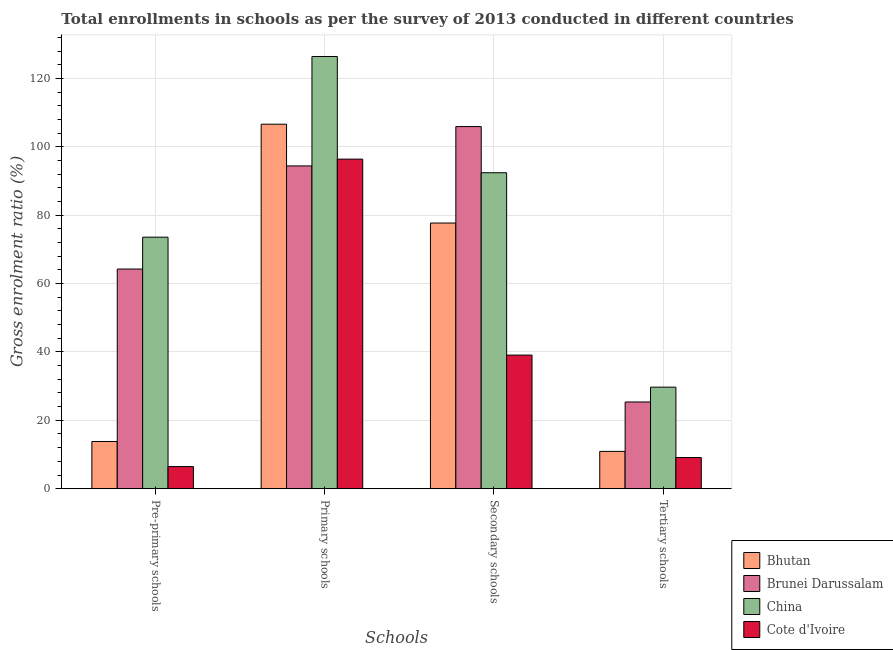How many groups of bars are there?
Offer a very short reply. 4. Are the number of bars per tick equal to the number of legend labels?
Give a very brief answer. Yes. What is the label of the 2nd group of bars from the left?
Ensure brevity in your answer.  Primary schools. What is the gross enrolment ratio in pre-primary schools in Bhutan?
Your answer should be very brief. 13.79. Across all countries, what is the maximum gross enrolment ratio in pre-primary schools?
Offer a terse response. 73.56. Across all countries, what is the minimum gross enrolment ratio in tertiary schools?
Keep it short and to the point. 9.1. In which country was the gross enrolment ratio in pre-primary schools minimum?
Give a very brief answer. Cote d'Ivoire. What is the total gross enrolment ratio in pre-primary schools in the graph?
Provide a succinct answer. 158.06. What is the difference between the gross enrolment ratio in secondary schools in Cote d'Ivoire and that in China?
Provide a short and direct response. -53.33. What is the difference between the gross enrolment ratio in primary schools in China and the gross enrolment ratio in tertiary schools in Bhutan?
Offer a very short reply. 115.51. What is the average gross enrolment ratio in tertiary schools per country?
Offer a very short reply. 18.77. What is the difference between the gross enrolment ratio in tertiary schools and gross enrolment ratio in primary schools in Bhutan?
Ensure brevity in your answer.  -95.7. What is the ratio of the gross enrolment ratio in secondary schools in Brunei Darussalam to that in China?
Provide a short and direct response. 1.15. Is the gross enrolment ratio in pre-primary schools in Bhutan less than that in Cote d'Ivoire?
Your response must be concise. No. Is the difference between the gross enrolment ratio in secondary schools in Bhutan and Cote d'Ivoire greater than the difference between the gross enrolment ratio in pre-primary schools in Bhutan and Cote d'Ivoire?
Offer a terse response. Yes. What is the difference between the highest and the second highest gross enrolment ratio in secondary schools?
Keep it short and to the point. 13.5. What is the difference between the highest and the lowest gross enrolment ratio in primary schools?
Provide a short and direct response. 32.01. Is the sum of the gross enrolment ratio in tertiary schools in China and Cote d'Ivoire greater than the maximum gross enrolment ratio in primary schools across all countries?
Provide a succinct answer. No. Is it the case that in every country, the sum of the gross enrolment ratio in pre-primary schools and gross enrolment ratio in primary schools is greater than the sum of gross enrolment ratio in secondary schools and gross enrolment ratio in tertiary schools?
Keep it short and to the point. Yes. What does the 4th bar from the left in Secondary schools represents?
Provide a short and direct response. Cote d'Ivoire. What does the 3rd bar from the right in Primary schools represents?
Your answer should be compact. Brunei Darussalam. How many countries are there in the graph?
Your response must be concise. 4. What is the difference between two consecutive major ticks on the Y-axis?
Provide a short and direct response. 20. Are the values on the major ticks of Y-axis written in scientific E-notation?
Ensure brevity in your answer.  No. Does the graph contain grids?
Offer a very short reply. Yes. How many legend labels are there?
Your answer should be compact. 4. How are the legend labels stacked?
Give a very brief answer. Vertical. What is the title of the graph?
Offer a terse response. Total enrollments in schools as per the survey of 2013 conducted in different countries. What is the label or title of the X-axis?
Your answer should be very brief. Schools. What is the Gross enrolment ratio (%) in Bhutan in Pre-primary schools?
Give a very brief answer. 13.79. What is the Gross enrolment ratio (%) in Brunei Darussalam in Pre-primary schools?
Offer a very short reply. 64.24. What is the Gross enrolment ratio (%) of China in Pre-primary schools?
Offer a terse response. 73.56. What is the Gross enrolment ratio (%) of Cote d'Ivoire in Pre-primary schools?
Your answer should be compact. 6.46. What is the Gross enrolment ratio (%) of Bhutan in Primary schools?
Your response must be concise. 106.61. What is the Gross enrolment ratio (%) of Brunei Darussalam in Primary schools?
Your answer should be compact. 94.41. What is the Gross enrolment ratio (%) of China in Primary schools?
Provide a succinct answer. 126.42. What is the Gross enrolment ratio (%) of Cote d'Ivoire in Primary schools?
Provide a short and direct response. 96.4. What is the Gross enrolment ratio (%) of Bhutan in Secondary schools?
Offer a terse response. 77.7. What is the Gross enrolment ratio (%) of Brunei Darussalam in Secondary schools?
Offer a very short reply. 105.91. What is the Gross enrolment ratio (%) of China in Secondary schools?
Give a very brief answer. 92.41. What is the Gross enrolment ratio (%) in Cote d'Ivoire in Secondary schools?
Keep it short and to the point. 39.08. What is the Gross enrolment ratio (%) of Bhutan in Tertiary schools?
Your answer should be very brief. 10.91. What is the Gross enrolment ratio (%) in Brunei Darussalam in Tertiary schools?
Offer a terse response. 25.36. What is the Gross enrolment ratio (%) in China in Tertiary schools?
Your response must be concise. 29.7. What is the Gross enrolment ratio (%) of Cote d'Ivoire in Tertiary schools?
Make the answer very short. 9.1. Across all Schools, what is the maximum Gross enrolment ratio (%) in Bhutan?
Ensure brevity in your answer.  106.61. Across all Schools, what is the maximum Gross enrolment ratio (%) in Brunei Darussalam?
Your answer should be compact. 105.91. Across all Schools, what is the maximum Gross enrolment ratio (%) of China?
Your response must be concise. 126.42. Across all Schools, what is the maximum Gross enrolment ratio (%) in Cote d'Ivoire?
Your answer should be compact. 96.4. Across all Schools, what is the minimum Gross enrolment ratio (%) in Bhutan?
Your answer should be very brief. 10.91. Across all Schools, what is the minimum Gross enrolment ratio (%) of Brunei Darussalam?
Your response must be concise. 25.36. Across all Schools, what is the minimum Gross enrolment ratio (%) of China?
Make the answer very short. 29.7. Across all Schools, what is the minimum Gross enrolment ratio (%) in Cote d'Ivoire?
Your answer should be very brief. 6.46. What is the total Gross enrolment ratio (%) of Bhutan in the graph?
Ensure brevity in your answer.  209.01. What is the total Gross enrolment ratio (%) in Brunei Darussalam in the graph?
Offer a terse response. 289.92. What is the total Gross enrolment ratio (%) in China in the graph?
Your response must be concise. 322.09. What is the total Gross enrolment ratio (%) of Cote d'Ivoire in the graph?
Provide a short and direct response. 151.04. What is the difference between the Gross enrolment ratio (%) of Bhutan in Pre-primary schools and that in Primary schools?
Give a very brief answer. -92.81. What is the difference between the Gross enrolment ratio (%) of Brunei Darussalam in Pre-primary schools and that in Primary schools?
Your answer should be compact. -30.16. What is the difference between the Gross enrolment ratio (%) of China in Pre-primary schools and that in Primary schools?
Ensure brevity in your answer.  -52.85. What is the difference between the Gross enrolment ratio (%) in Cote d'Ivoire in Pre-primary schools and that in Primary schools?
Ensure brevity in your answer.  -89.93. What is the difference between the Gross enrolment ratio (%) in Bhutan in Pre-primary schools and that in Secondary schools?
Your answer should be very brief. -63.91. What is the difference between the Gross enrolment ratio (%) of Brunei Darussalam in Pre-primary schools and that in Secondary schools?
Provide a short and direct response. -41.67. What is the difference between the Gross enrolment ratio (%) of China in Pre-primary schools and that in Secondary schools?
Your answer should be compact. -18.84. What is the difference between the Gross enrolment ratio (%) in Cote d'Ivoire in Pre-primary schools and that in Secondary schools?
Give a very brief answer. -32.61. What is the difference between the Gross enrolment ratio (%) in Bhutan in Pre-primary schools and that in Tertiary schools?
Offer a terse response. 2.88. What is the difference between the Gross enrolment ratio (%) in Brunei Darussalam in Pre-primary schools and that in Tertiary schools?
Provide a short and direct response. 38.88. What is the difference between the Gross enrolment ratio (%) in China in Pre-primary schools and that in Tertiary schools?
Your response must be concise. 43.87. What is the difference between the Gross enrolment ratio (%) in Cote d'Ivoire in Pre-primary schools and that in Tertiary schools?
Provide a succinct answer. -2.64. What is the difference between the Gross enrolment ratio (%) in Bhutan in Primary schools and that in Secondary schools?
Offer a terse response. 28.91. What is the difference between the Gross enrolment ratio (%) of Brunei Darussalam in Primary schools and that in Secondary schools?
Your response must be concise. -11.5. What is the difference between the Gross enrolment ratio (%) of China in Primary schools and that in Secondary schools?
Provide a succinct answer. 34.01. What is the difference between the Gross enrolment ratio (%) of Cote d'Ivoire in Primary schools and that in Secondary schools?
Make the answer very short. 57.32. What is the difference between the Gross enrolment ratio (%) in Bhutan in Primary schools and that in Tertiary schools?
Provide a short and direct response. 95.7. What is the difference between the Gross enrolment ratio (%) of Brunei Darussalam in Primary schools and that in Tertiary schools?
Offer a terse response. 69.04. What is the difference between the Gross enrolment ratio (%) of China in Primary schools and that in Tertiary schools?
Offer a terse response. 96.72. What is the difference between the Gross enrolment ratio (%) of Cote d'Ivoire in Primary schools and that in Tertiary schools?
Your response must be concise. 87.29. What is the difference between the Gross enrolment ratio (%) of Bhutan in Secondary schools and that in Tertiary schools?
Provide a short and direct response. 66.79. What is the difference between the Gross enrolment ratio (%) in Brunei Darussalam in Secondary schools and that in Tertiary schools?
Your answer should be compact. 80.55. What is the difference between the Gross enrolment ratio (%) in China in Secondary schools and that in Tertiary schools?
Ensure brevity in your answer.  62.71. What is the difference between the Gross enrolment ratio (%) of Cote d'Ivoire in Secondary schools and that in Tertiary schools?
Give a very brief answer. 29.97. What is the difference between the Gross enrolment ratio (%) of Bhutan in Pre-primary schools and the Gross enrolment ratio (%) of Brunei Darussalam in Primary schools?
Ensure brevity in your answer.  -80.61. What is the difference between the Gross enrolment ratio (%) in Bhutan in Pre-primary schools and the Gross enrolment ratio (%) in China in Primary schools?
Give a very brief answer. -112.62. What is the difference between the Gross enrolment ratio (%) of Bhutan in Pre-primary schools and the Gross enrolment ratio (%) of Cote d'Ivoire in Primary schools?
Offer a terse response. -82.6. What is the difference between the Gross enrolment ratio (%) in Brunei Darussalam in Pre-primary schools and the Gross enrolment ratio (%) in China in Primary schools?
Offer a terse response. -62.17. What is the difference between the Gross enrolment ratio (%) in Brunei Darussalam in Pre-primary schools and the Gross enrolment ratio (%) in Cote d'Ivoire in Primary schools?
Provide a succinct answer. -32.15. What is the difference between the Gross enrolment ratio (%) of China in Pre-primary schools and the Gross enrolment ratio (%) of Cote d'Ivoire in Primary schools?
Keep it short and to the point. -22.83. What is the difference between the Gross enrolment ratio (%) of Bhutan in Pre-primary schools and the Gross enrolment ratio (%) of Brunei Darussalam in Secondary schools?
Provide a short and direct response. -92.11. What is the difference between the Gross enrolment ratio (%) in Bhutan in Pre-primary schools and the Gross enrolment ratio (%) in China in Secondary schools?
Provide a succinct answer. -78.61. What is the difference between the Gross enrolment ratio (%) in Bhutan in Pre-primary schools and the Gross enrolment ratio (%) in Cote d'Ivoire in Secondary schools?
Ensure brevity in your answer.  -25.28. What is the difference between the Gross enrolment ratio (%) in Brunei Darussalam in Pre-primary schools and the Gross enrolment ratio (%) in China in Secondary schools?
Keep it short and to the point. -28.17. What is the difference between the Gross enrolment ratio (%) of Brunei Darussalam in Pre-primary schools and the Gross enrolment ratio (%) of Cote d'Ivoire in Secondary schools?
Ensure brevity in your answer.  25.17. What is the difference between the Gross enrolment ratio (%) of China in Pre-primary schools and the Gross enrolment ratio (%) of Cote d'Ivoire in Secondary schools?
Make the answer very short. 34.49. What is the difference between the Gross enrolment ratio (%) of Bhutan in Pre-primary schools and the Gross enrolment ratio (%) of Brunei Darussalam in Tertiary schools?
Your response must be concise. -11.57. What is the difference between the Gross enrolment ratio (%) of Bhutan in Pre-primary schools and the Gross enrolment ratio (%) of China in Tertiary schools?
Provide a succinct answer. -15.9. What is the difference between the Gross enrolment ratio (%) of Bhutan in Pre-primary schools and the Gross enrolment ratio (%) of Cote d'Ivoire in Tertiary schools?
Your answer should be very brief. 4.69. What is the difference between the Gross enrolment ratio (%) in Brunei Darussalam in Pre-primary schools and the Gross enrolment ratio (%) in China in Tertiary schools?
Give a very brief answer. 34.55. What is the difference between the Gross enrolment ratio (%) in Brunei Darussalam in Pre-primary schools and the Gross enrolment ratio (%) in Cote d'Ivoire in Tertiary schools?
Make the answer very short. 55.14. What is the difference between the Gross enrolment ratio (%) of China in Pre-primary schools and the Gross enrolment ratio (%) of Cote d'Ivoire in Tertiary schools?
Provide a short and direct response. 64.46. What is the difference between the Gross enrolment ratio (%) in Bhutan in Primary schools and the Gross enrolment ratio (%) in Brunei Darussalam in Secondary schools?
Offer a very short reply. 0.7. What is the difference between the Gross enrolment ratio (%) in Bhutan in Primary schools and the Gross enrolment ratio (%) in China in Secondary schools?
Your response must be concise. 14.2. What is the difference between the Gross enrolment ratio (%) in Bhutan in Primary schools and the Gross enrolment ratio (%) in Cote d'Ivoire in Secondary schools?
Provide a short and direct response. 67.53. What is the difference between the Gross enrolment ratio (%) in Brunei Darussalam in Primary schools and the Gross enrolment ratio (%) in China in Secondary schools?
Ensure brevity in your answer.  2. What is the difference between the Gross enrolment ratio (%) of Brunei Darussalam in Primary schools and the Gross enrolment ratio (%) of Cote d'Ivoire in Secondary schools?
Your response must be concise. 55.33. What is the difference between the Gross enrolment ratio (%) in China in Primary schools and the Gross enrolment ratio (%) in Cote d'Ivoire in Secondary schools?
Give a very brief answer. 87.34. What is the difference between the Gross enrolment ratio (%) in Bhutan in Primary schools and the Gross enrolment ratio (%) in Brunei Darussalam in Tertiary schools?
Make the answer very short. 81.25. What is the difference between the Gross enrolment ratio (%) of Bhutan in Primary schools and the Gross enrolment ratio (%) of China in Tertiary schools?
Give a very brief answer. 76.91. What is the difference between the Gross enrolment ratio (%) of Bhutan in Primary schools and the Gross enrolment ratio (%) of Cote d'Ivoire in Tertiary schools?
Your answer should be very brief. 97.5. What is the difference between the Gross enrolment ratio (%) of Brunei Darussalam in Primary schools and the Gross enrolment ratio (%) of China in Tertiary schools?
Your answer should be very brief. 64.71. What is the difference between the Gross enrolment ratio (%) of Brunei Darussalam in Primary schools and the Gross enrolment ratio (%) of Cote d'Ivoire in Tertiary schools?
Provide a short and direct response. 85.3. What is the difference between the Gross enrolment ratio (%) of China in Primary schools and the Gross enrolment ratio (%) of Cote d'Ivoire in Tertiary schools?
Keep it short and to the point. 117.31. What is the difference between the Gross enrolment ratio (%) of Bhutan in Secondary schools and the Gross enrolment ratio (%) of Brunei Darussalam in Tertiary schools?
Ensure brevity in your answer.  52.34. What is the difference between the Gross enrolment ratio (%) of Bhutan in Secondary schools and the Gross enrolment ratio (%) of China in Tertiary schools?
Make the answer very short. 48. What is the difference between the Gross enrolment ratio (%) of Bhutan in Secondary schools and the Gross enrolment ratio (%) of Cote d'Ivoire in Tertiary schools?
Provide a succinct answer. 68.6. What is the difference between the Gross enrolment ratio (%) in Brunei Darussalam in Secondary schools and the Gross enrolment ratio (%) in China in Tertiary schools?
Provide a short and direct response. 76.21. What is the difference between the Gross enrolment ratio (%) in Brunei Darussalam in Secondary schools and the Gross enrolment ratio (%) in Cote d'Ivoire in Tertiary schools?
Ensure brevity in your answer.  96.81. What is the difference between the Gross enrolment ratio (%) in China in Secondary schools and the Gross enrolment ratio (%) in Cote d'Ivoire in Tertiary schools?
Your response must be concise. 83.31. What is the average Gross enrolment ratio (%) in Bhutan per Schools?
Ensure brevity in your answer.  52.25. What is the average Gross enrolment ratio (%) in Brunei Darussalam per Schools?
Offer a very short reply. 72.48. What is the average Gross enrolment ratio (%) in China per Schools?
Give a very brief answer. 80.52. What is the average Gross enrolment ratio (%) in Cote d'Ivoire per Schools?
Keep it short and to the point. 37.76. What is the difference between the Gross enrolment ratio (%) of Bhutan and Gross enrolment ratio (%) of Brunei Darussalam in Pre-primary schools?
Ensure brevity in your answer.  -50.45. What is the difference between the Gross enrolment ratio (%) of Bhutan and Gross enrolment ratio (%) of China in Pre-primary schools?
Give a very brief answer. -59.77. What is the difference between the Gross enrolment ratio (%) of Bhutan and Gross enrolment ratio (%) of Cote d'Ivoire in Pre-primary schools?
Give a very brief answer. 7.33. What is the difference between the Gross enrolment ratio (%) in Brunei Darussalam and Gross enrolment ratio (%) in China in Pre-primary schools?
Provide a succinct answer. -9.32. What is the difference between the Gross enrolment ratio (%) of Brunei Darussalam and Gross enrolment ratio (%) of Cote d'Ivoire in Pre-primary schools?
Offer a terse response. 57.78. What is the difference between the Gross enrolment ratio (%) of China and Gross enrolment ratio (%) of Cote d'Ivoire in Pre-primary schools?
Your answer should be compact. 67.1. What is the difference between the Gross enrolment ratio (%) of Bhutan and Gross enrolment ratio (%) of Brunei Darussalam in Primary schools?
Provide a succinct answer. 12.2. What is the difference between the Gross enrolment ratio (%) of Bhutan and Gross enrolment ratio (%) of China in Primary schools?
Provide a succinct answer. -19.81. What is the difference between the Gross enrolment ratio (%) of Bhutan and Gross enrolment ratio (%) of Cote d'Ivoire in Primary schools?
Your response must be concise. 10.21. What is the difference between the Gross enrolment ratio (%) in Brunei Darussalam and Gross enrolment ratio (%) in China in Primary schools?
Your response must be concise. -32.01. What is the difference between the Gross enrolment ratio (%) of Brunei Darussalam and Gross enrolment ratio (%) of Cote d'Ivoire in Primary schools?
Ensure brevity in your answer.  -1.99. What is the difference between the Gross enrolment ratio (%) in China and Gross enrolment ratio (%) in Cote d'Ivoire in Primary schools?
Your answer should be compact. 30.02. What is the difference between the Gross enrolment ratio (%) in Bhutan and Gross enrolment ratio (%) in Brunei Darussalam in Secondary schools?
Make the answer very short. -28.21. What is the difference between the Gross enrolment ratio (%) of Bhutan and Gross enrolment ratio (%) of China in Secondary schools?
Your answer should be compact. -14.71. What is the difference between the Gross enrolment ratio (%) of Bhutan and Gross enrolment ratio (%) of Cote d'Ivoire in Secondary schools?
Ensure brevity in your answer.  38.63. What is the difference between the Gross enrolment ratio (%) of Brunei Darussalam and Gross enrolment ratio (%) of China in Secondary schools?
Make the answer very short. 13.5. What is the difference between the Gross enrolment ratio (%) in Brunei Darussalam and Gross enrolment ratio (%) in Cote d'Ivoire in Secondary schools?
Make the answer very short. 66.83. What is the difference between the Gross enrolment ratio (%) in China and Gross enrolment ratio (%) in Cote d'Ivoire in Secondary schools?
Make the answer very short. 53.33. What is the difference between the Gross enrolment ratio (%) in Bhutan and Gross enrolment ratio (%) in Brunei Darussalam in Tertiary schools?
Your answer should be compact. -14.45. What is the difference between the Gross enrolment ratio (%) of Bhutan and Gross enrolment ratio (%) of China in Tertiary schools?
Make the answer very short. -18.79. What is the difference between the Gross enrolment ratio (%) of Bhutan and Gross enrolment ratio (%) of Cote d'Ivoire in Tertiary schools?
Your answer should be very brief. 1.81. What is the difference between the Gross enrolment ratio (%) in Brunei Darussalam and Gross enrolment ratio (%) in China in Tertiary schools?
Give a very brief answer. -4.33. What is the difference between the Gross enrolment ratio (%) in Brunei Darussalam and Gross enrolment ratio (%) in Cote d'Ivoire in Tertiary schools?
Your answer should be compact. 16.26. What is the difference between the Gross enrolment ratio (%) in China and Gross enrolment ratio (%) in Cote d'Ivoire in Tertiary schools?
Your answer should be compact. 20.59. What is the ratio of the Gross enrolment ratio (%) of Bhutan in Pre-primary schools to that in Primary schools?
Your answer should be compact. 0.13. What is the ratio of the Gross enrolment ratio (%) in Brunei Darussalam in Pre-primary schools to that in Primary schools?
Your response must be concise. 0.68. What is the ratio of the Gross enrolment ratio (%) in China in Pre-primary schools to that in Primary schools?
Offer a terse response. 0.58. What is the ratio of the Gross enrolment ratio (%) of Cote d'Ivoire in Pre-primary schools to that in Primary schools?
Offer a very short reply. 0.07. What is the ratio of the Gross enrolment ratio (%) of Bhutan in Pre-primary schools to that in Secondary schools?
Provide a succinct answer. 0.18. What is the ratio of the Gross enrolment ratio (%) in Brunei Darussalam in Pre-primary schools to that in Secondary schools?
Provide a short and direct response. 0.61. What is the ratio of the Gross enrolment ratio (%) of China in Pre-primary schools to that in Secondary schools?
Offer a very short reply. 0.8. What is the ratio of the Gross enrolment ratio (%) in Cote d'Ivoire in Pre-primary schools to that in Secondary schools?
Keep it short and to the point. 0.17. What is the ratio of the Gross enrolment ratio (%) in Bhutan in Pre-primary schools to that in Tertiary schools?
Offer a terse response. 1.26. What is the ratio of the Gross enrolment ratio (%) in Brunei Darussalam in Pre-primary schools to that in Tertiary schools?
Offer a very short reply. 2.53. What is the ratio of the Gross enrolment ratio (%) of China in Pre-primary schools to that in Tertiary schools?
Keep it short and to the point. 2.48. What is the ratio of the Gross enrolment ratio (%) of Cote d'Ivoire in Pre-primary schools to that in Tertiary schools?
Your response must be concise. 0.71. What is the ratio of the Gross enrolment ratio (%) of Bhutan in Primary schools to that in Secondary schools?
Give a very brief answer. 1.37. What is the ratio of the Gross enrolment ratio (%) of Brunei Darussalam in Primary schools to that in Secondary schools?
Your answer should be very brief. 0.89. What is the ratio of the Gross enrolment ratio (%) in China in Primary schools to that in Secondary schools?
Provide a short and direct response. 1.37. What is the ratio of the Gross enrolment ratio (%) in Cote d'Ivoire in Primary schools to that in Secondary schools?
Ensure brevity in your answer.  2.47. What is the ratio of the Gross enrolment ratio (%) in Bhutan in Primary schools to that in Tertiary schools?
Give a very brief answer. 9.77. What is the ratio of the Gross enrolment ratio (%) in Brunei Darussalam in Primary schools to that in Tertiary schools?
Make the answer very short. 3.72. What is the ratio of the Gross enrolment ratio (%) in China in Primary schools to that in Tertiary schools?
Make the answer very short. 4.26. What is the ratio of the Gross enrolment ratio (%) in Cote d'Ivoire in Primary schools to that in Tertiary schools?
Ensure brevity in your answer.  10.59. What is the ratio of the Gross enrolment ratio (%) of Bhutan in Secondary schools to that in Tertiary schools?
Provide a succinct answer. 7.12. What is the ratio of the Gross enrolment ratio (%) in Brunei Darussalam in Secondary schools to that in Tertiary schools?
Make the answer very short. 4.18. What is the ratio of the Gross enrolment ratio (%) of China in Secondary schools to that in Tertiary schools?
Give a very brief answer. 3.11. What is the ratio of the Gross enrolment ratio (%) in Cote d'Ivoire in Secondary schools to that in Tertiary schools?
Offer a very short reply. 4.29. What is the difference between the highest and the second highest Gross enrolment ratio (%) in Bhutan?
Your response must be concise. 28.91. What is the difference between the highest and the second highest Gross enrolment ratio (%) in Brunei Darussalam?
Your answer should be compact. 11.5. What is the difference between the highest and the second highest Gross enrolment ratio (%) of China?
Ensure brevity in your answer.  34.01. What is the difference between the highest and the second highest Gross enrolment ratio (%) of Cote d'Ivoire?
Offer a terse response. 57.32. What is the difference between the highest and the lowest Gross enrolment ratio (%) in Bhutan?
Your answer should be compact. 95.7. What is the difference between the highest and the lowest Gross enrolment ratio (%) in Brunei Darussalam?
Provide a short and direct response. 80.55. What is the difference between the highest and the lowest Gross enrolment ratio (%) of China?
Ensure brevity in your answer.  96.72. What is the difference between the highest and the lowest Gross enrolment ratio (%) of Cote d'Ivoire?
Ensure brevity in your answer.  89.93. 